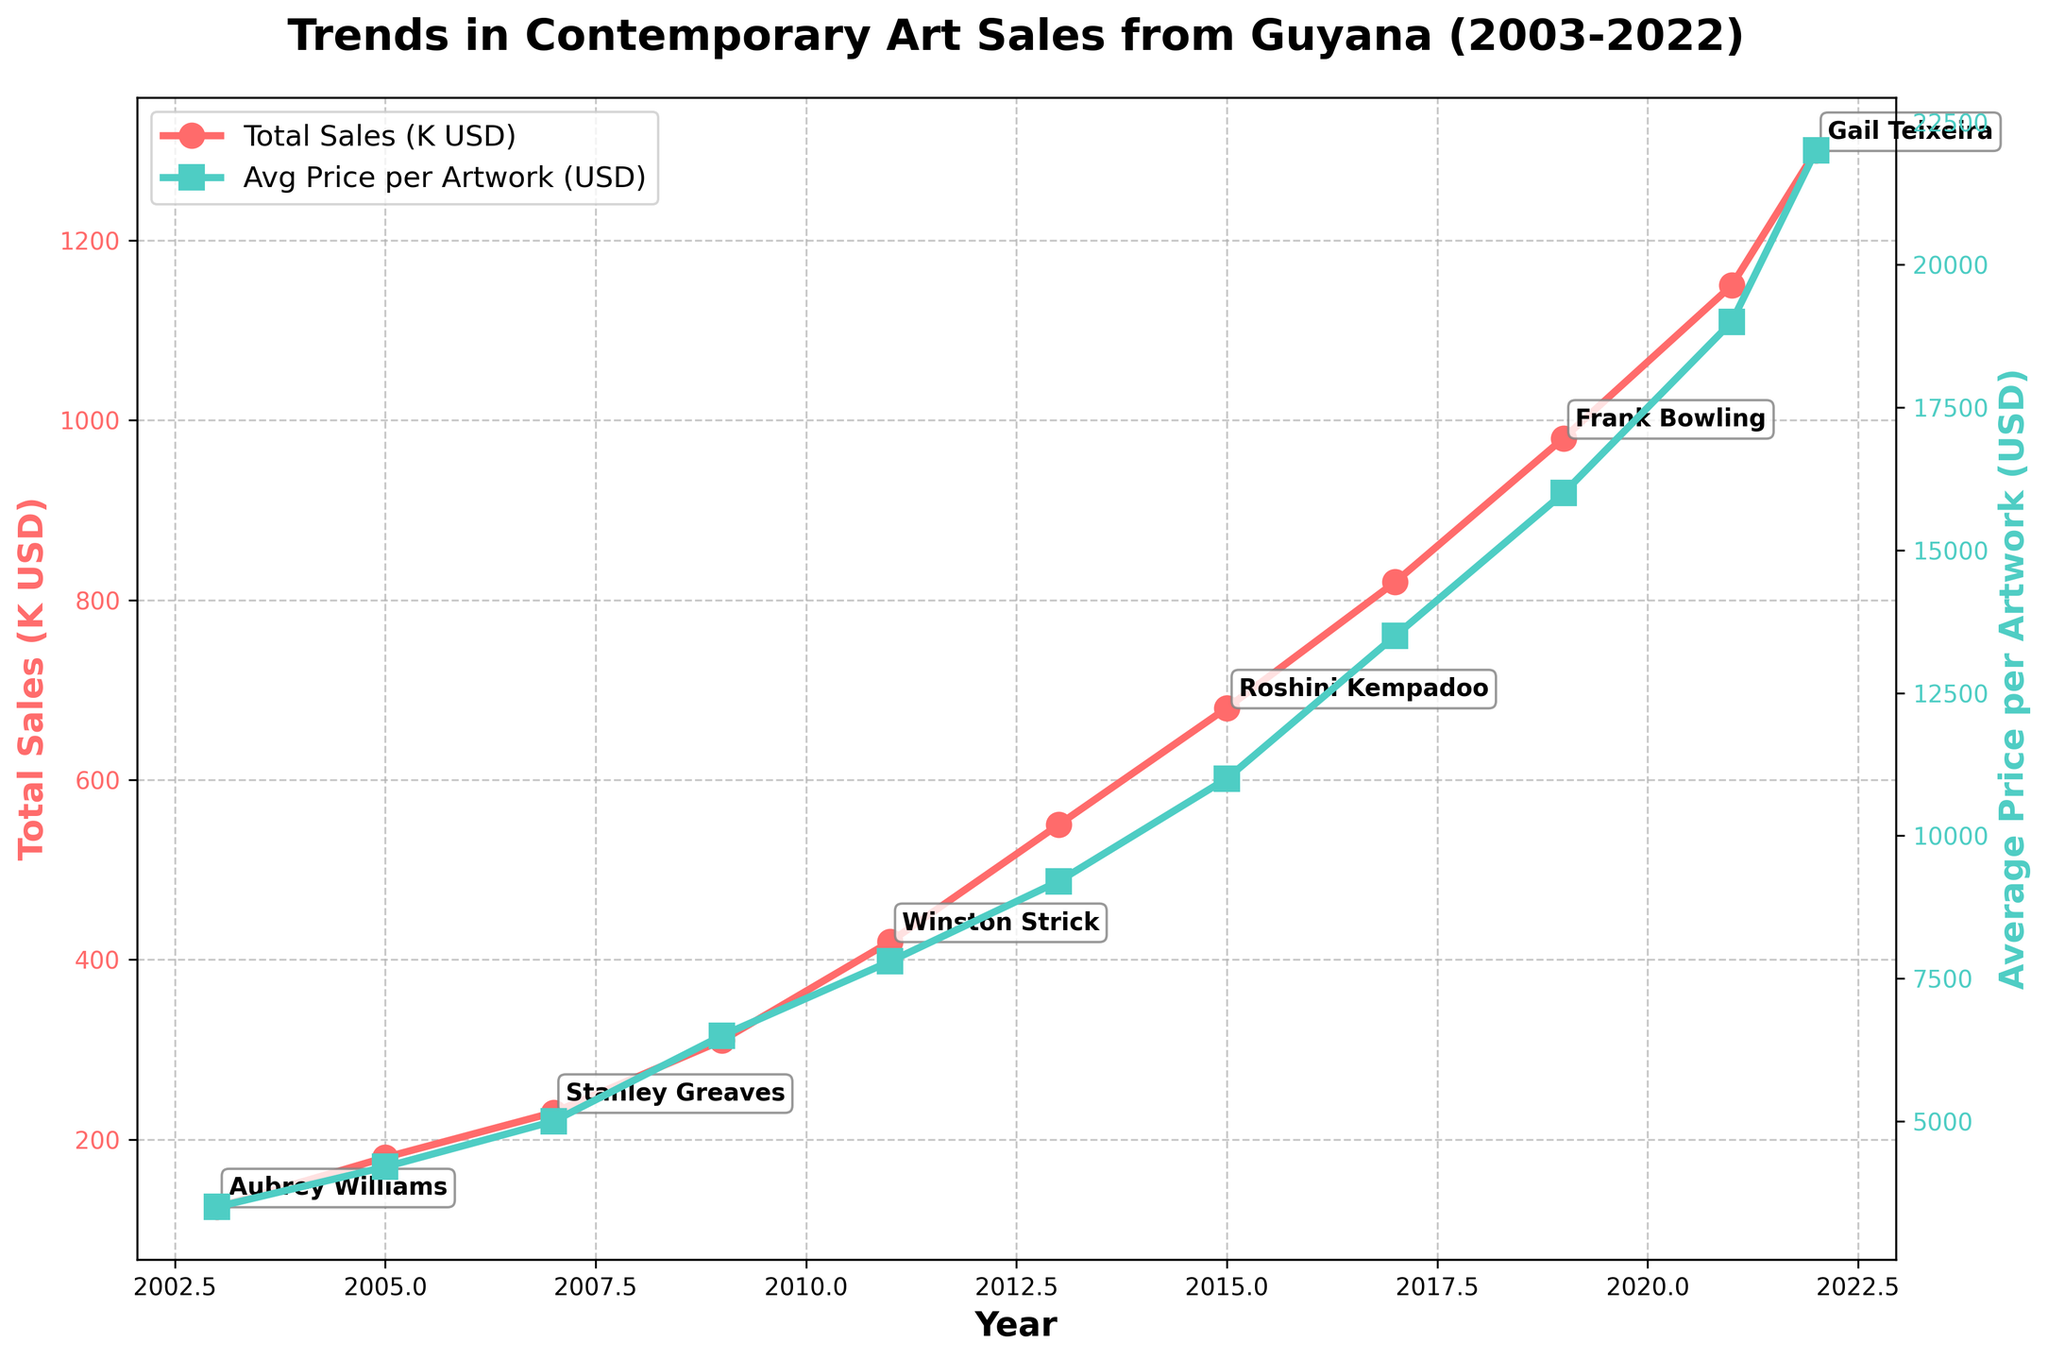What's the overall trend in total sales of contemporary art from Guyana between 2003 and 2022? The red line representing 'Total Sales (K USD)' shows a consistent upward trend from 125,000 USD in 2003 to 1,300,000 USD in 2022. This indicates a growing market and increasing sales over the years.
Answer: Upward trend What is the relationship between the year and the average price per artwork? The green line representing 'Avg Price per Artwork (USD)' shows an upward trend from 3,500 USD in 2003 to 22,000 USD in 2022. This relationship indicates that as the years progress, the average price per artwork also increases.
Answer: Increasing over the years Which year had the highest total sales? The highest point on the red line is at 2022 with total sales of 1300K USD (1,300,000 USD).
Answer: 2022 Who was the top-selling artist in 2017? The annotation near the point for the year 2017 on the red line indicates that Donald Locke was the top-selling artist in that year.
Answer: Donald Locke How does the trend of total sales compare to the trend of average price per artwork? Both the red line (Total Sales) and the green line (Avg Price per Artwork) show a positive, increasing trend over the years. However, the total sales line shows a steeper increase compared to the average price line.
Answer: Both increasing, total sales steeper Considering the years 2003 and 2011, how much did the total sales increase, and what’s the percentage increase? Total sales in 2003 are 125K USD and in 2011 are 420K USD. The increase is 420K - 125K = 295K USD. The percentage increase is (295K / 125K) * 100 = 236%.
Answer: 295K USD, 236% During which years did the average price per artwork exceed 10,000 USD? The green line for Avg Price per Artwork exceeds the 10,000 USD mark starting from 2015 and continues through 2017, 2019, 2021, and 2022.
Answer: 2015, 2017, 2019, 2021, 2022 What’s the average total sales from 2003 to 2022? Summing the total sales figures from 2003 to 2022 gives 6,825,000 USD. There are 10 data points, so the average total sales are 6,825,000 / 10 = 682,500 USD.
Answer: 682,500 USD Which year had the highest average price per artwork, and what was it? The peak point of the green line for Avg Price per Artwork is at 2022, where the average price per artwork is 22,000 USD.
Answer: 2022, 22,000 USD In which decade (2000-2010 and 2010-2020) did total sales grow more rapidly? From 2003 to 2010, the total sales increased from 125,000 to 310,000 USD (an increase of 185,000). From 2011 to 2020, the total sales increased from 420,000 to 1,150,000 USD (an increase of 730,000). Therefore, the growth was more rapid from 2010-2020.
Answer: 2010-2020 